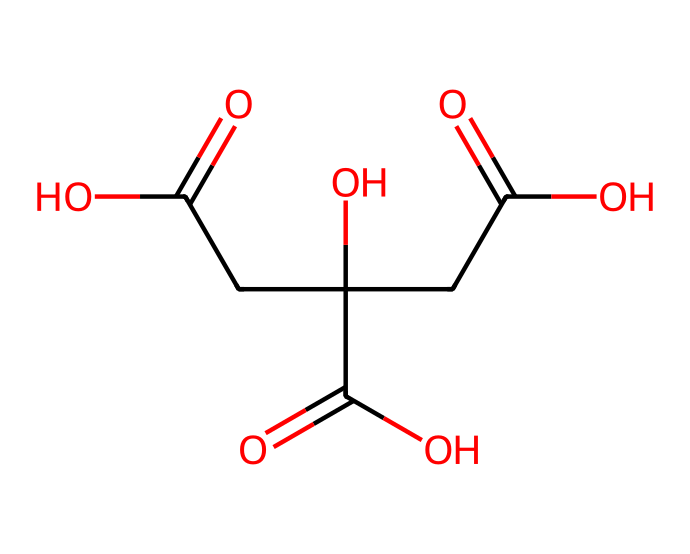how many carboxylic acid groups are present in citric acid? The structure of citric acid reveals three carboxyl (-COOH) groups, as evidenced by the three occurrences of carbon atoms bonded to a hydroxyl and double-bonded to oxygen.
Answer: three what is the molecular weight of citric acid? By analyzing the structure and counting the atoms in the SMILES code, citric acid has a molecular weight of 192.13 g/mol based on the atomic weights of carbon, hydrogen, and oxygen involved.
Answer: 192.13 what functional groups are present in citric acid? The structure contains carboxylic acid (-COOH) and hydroxyl (-OH) functional groups, which are indicated by the presence of -COOH and -OH in the molecular arrangement.
Answer: carboxylic acid and hydroxyl how many total carbon atoms are in citric acid? In the SMILES structure, there are six carbon atoms, which can be counted directly within the representation.
Answer: six is citric acid a weak or strong acid? Citric acid is classified as a weak acid because it does not completely dissociate in solution, a characteristic typical of organic acids like citric acid.
Answer: weak what is the role of citric acid in throat lozenges? Citric acid acts primarily as a flavoring agent, providing a tart taste that can mask other flavors and enhance the lozenge's efficacy in soothing the throat.
Answer: flavoring agent does citric acid have any buffering capacity? Yes, citric acid can act as a buffer, helping to maintain pH levels in solutions due to its proton-donating and -accepting abilities, especially in biological systems.
Answer: yes 